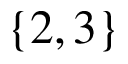Convert formula to latex. <formula><loc_0><loc_0><loc_500><loc_500>\{ 2 , 3 \}</formula> 